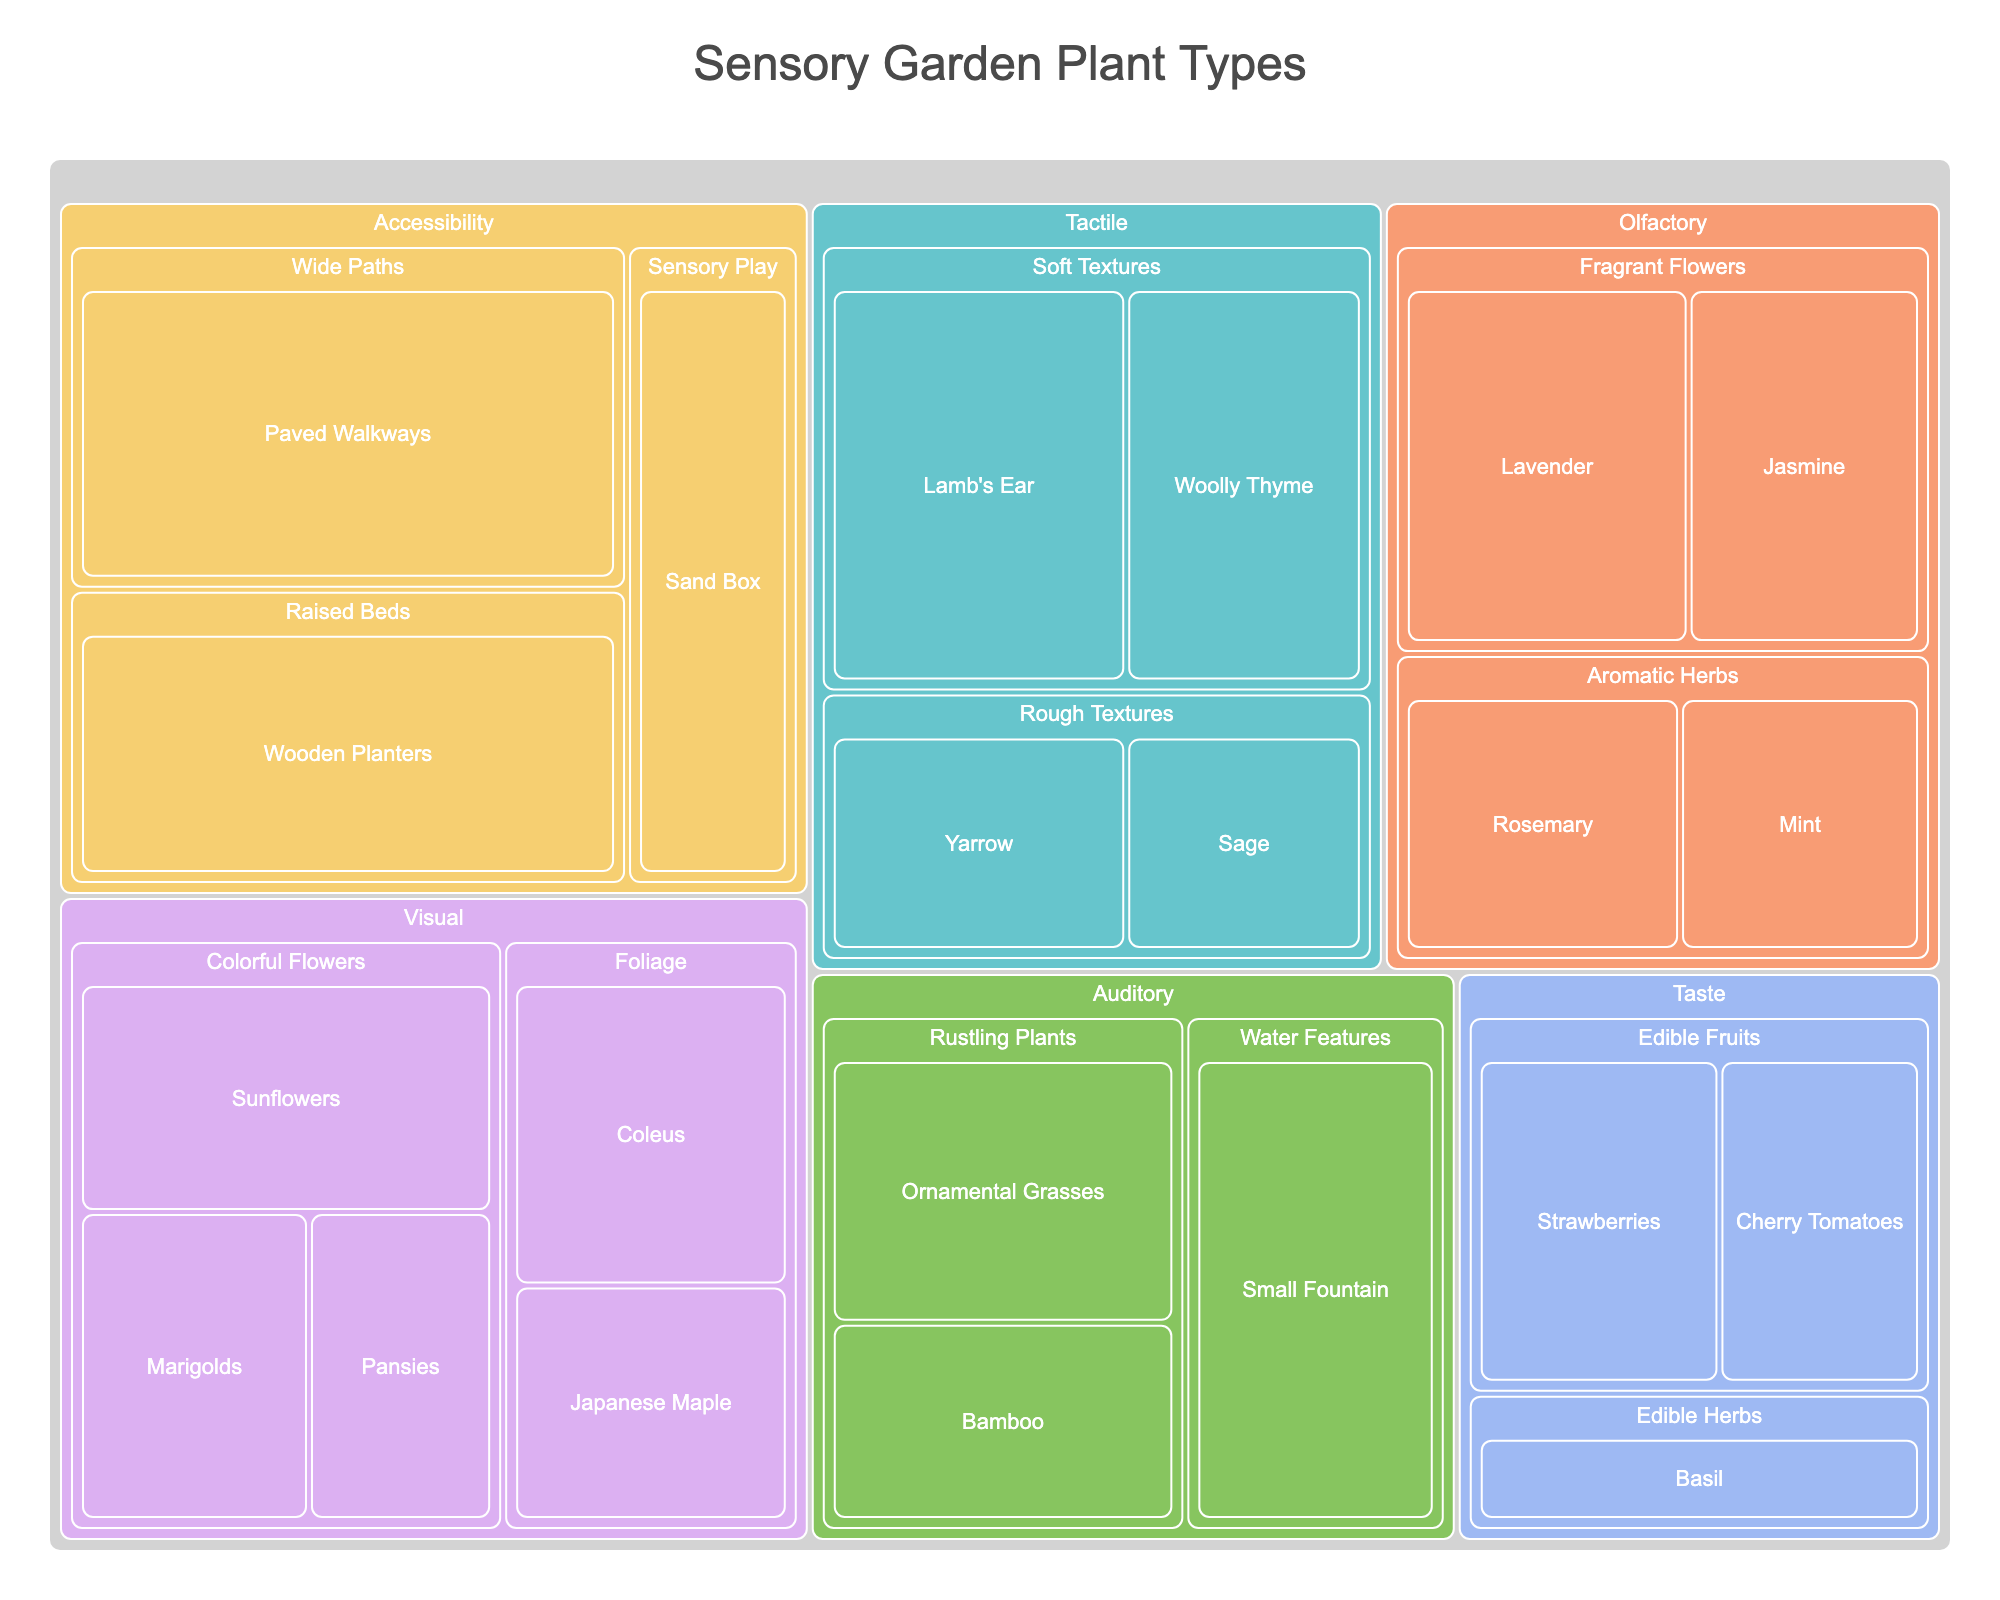How many plant categories are there in the figure? Look at the top-level categories in the hierarchy of the Treemap. The top layer shows categories such as Visual, Tactile, Olfactory, Auditory, Taste, and Accessibility. Count these categories.
Answer: 6 Which subcategory has the highest value in the Accessibility category? In the Accessibility category, compare the values of the subcategories Raised Beds, Wide Paths, and Sensory Play. Wide Paths has the highest value of 35.
Answer: Wide Paths Compare the values of Sunflowers and Lavender. Which one has a higher value? Find Sunflowers in Visual - Colorful Flowers and Lavender in Olfactory - Fragrant Flowers. Sunflowers have a value of 20, while Lavender has a value of 22. Lavender has a higher value.
Answer: Lavender What is the total value of plants in the Visual category? Add the values of Sunflowers (20), Marigolds (15), Pansies (12), Coleus (18), and Japanese Maple (14). The total is 20 + 15 + 12 + 18 + 14.
Answer: 79 Which plant in the Tactile category has the lowest value? Look within the Tactile category and compare the values of Lamb's Ear (25), Woolly Thyme (20), Yarrow (15), and Sage (12). Sage has the lowest value.
Answer: Sage How many plants are there in the Olfactory category? Count the plants in the subcategories of Fragrant Flowers and Aromatic Herbs within the Olfactory category: Lavender, Jasmine, Rosemary, and Mint.
Answer: 4 Which category has the smallest total value? Calculate the sum of values in all categories and compare. Tactile has (25 + 20 + 15 + 12) = 72, Visual has (20 + 15 + 12 + 18 + 14) = 79, Olfactory has (22 + 18 + 16 + 14) = 70, Auditory has (20 + 15 + 25) = 60, Taste has (18 + 15 + 12) = 45, Accessibility has (30 + 35 + 20) = 85. The smallest total is Taste with 45.
Answer: Taste What is the average value of the plant types in the Taste category? Add the values of Strawberries (18), Cherry Tomatoes (15), and Basil (12), then divide by the number of types (3). The total is 18 + 15 + 12 = 45, and the average is 45 / 3.
Answer: 15 Which plant has the highest value in the Auditory category? Compare the plants in the Auditory category: Ornamental Grasses (20), Bamboo (15), Small Fountain (25). Small Fountain has the highest value.
Answer: Small Fountain 